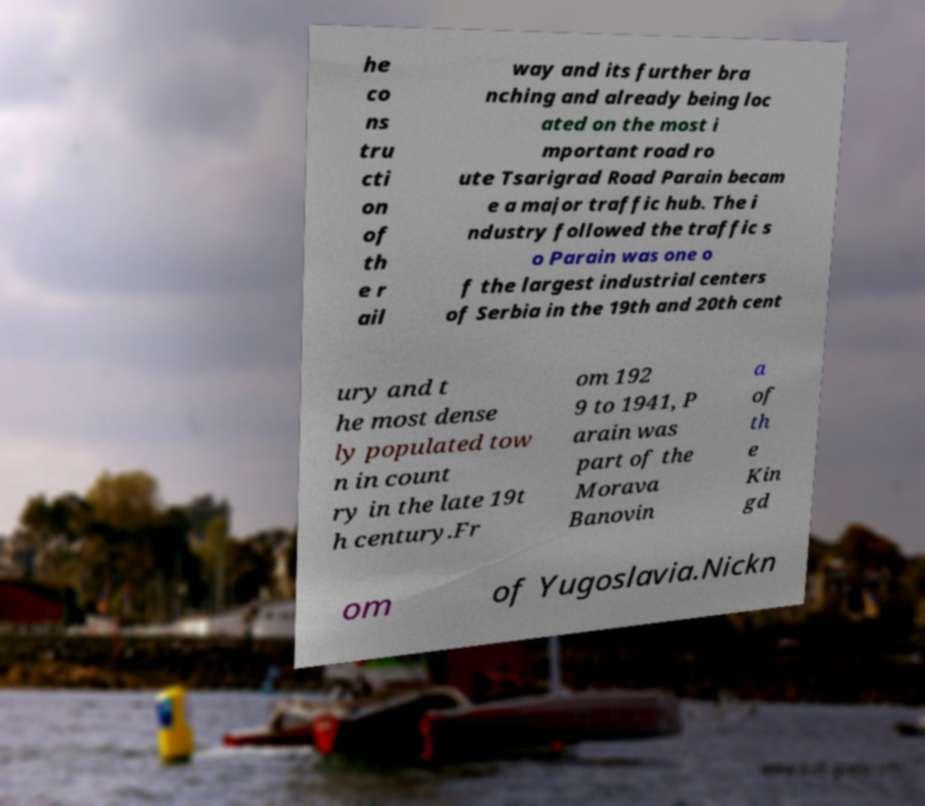Please identify and transcribe the text found in this image. he co ns tru cti on of th e r ail way and its further bra nching and already being loc ated on the most i mportant road ro ute Tsarigrad Road Parain becam e a major traffic hub. The i ndustry followed the traffic s o Parain was one o f the largest industrial centers of Serbia in the 19th and 20th cent ury and t he most dense ly populated tow n in count ry in the late 19t h century.Fr om 192 9 to 1941, P arain was part of the Morava Banovin a of th e Kin gd om of Yugoslavia.Nickn 